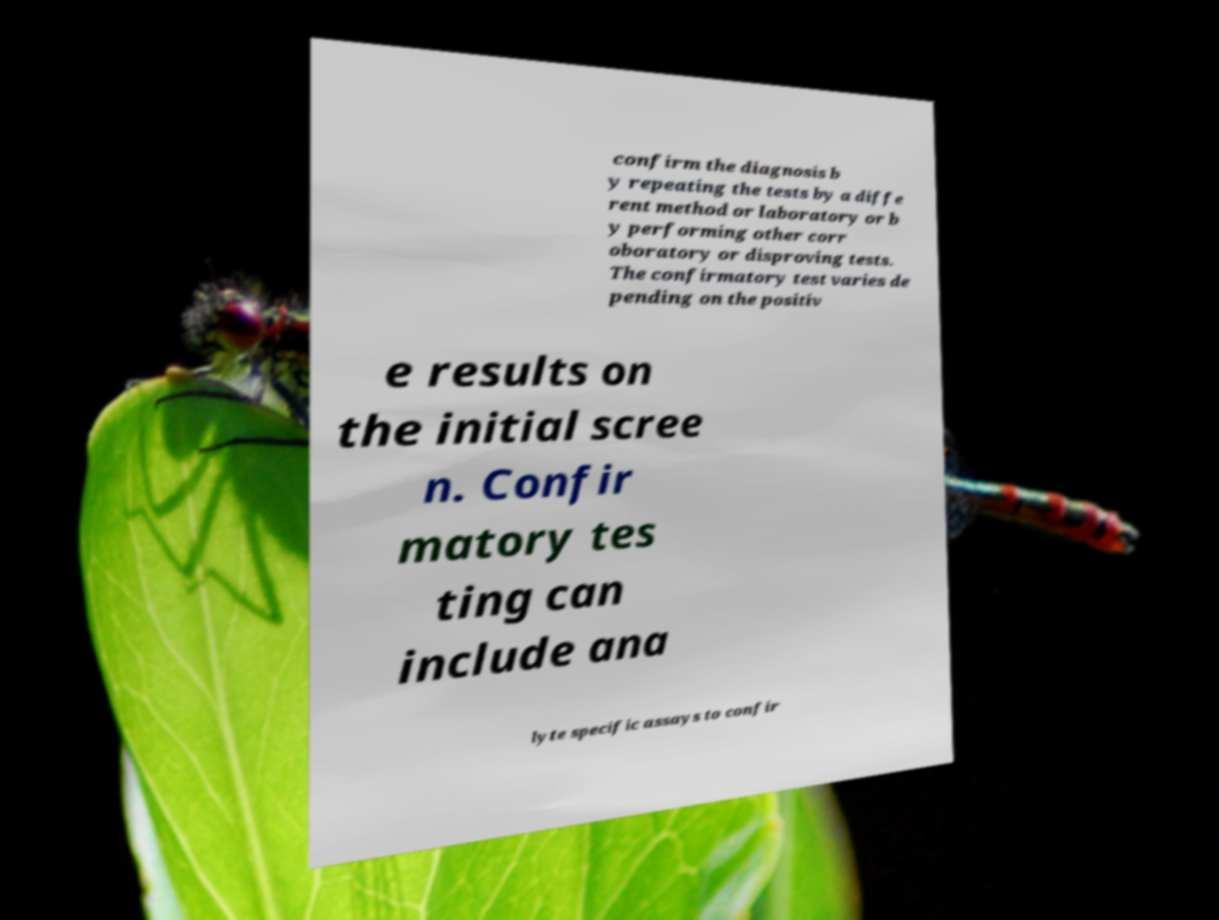Please read and relay the text visible in this image. What does it say? confirm the diagnosis b y repeating the tests by a diffe rent method or laboratory or b y performing other corr oboratory or disproving tests. The confirmatory test varies de pending on the positiv e results on the initial scree n. Confir matory tes ting can include ana lyte specific assays to confir 